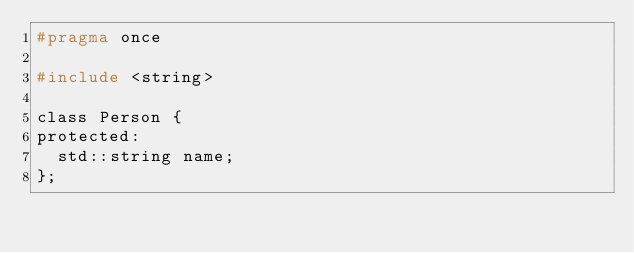<code> <loc_0><loc_0><loc_500><loc_500><_C_>#pragma once

#include <string>

class Person {
protected:
	std::string name;
};</code> 